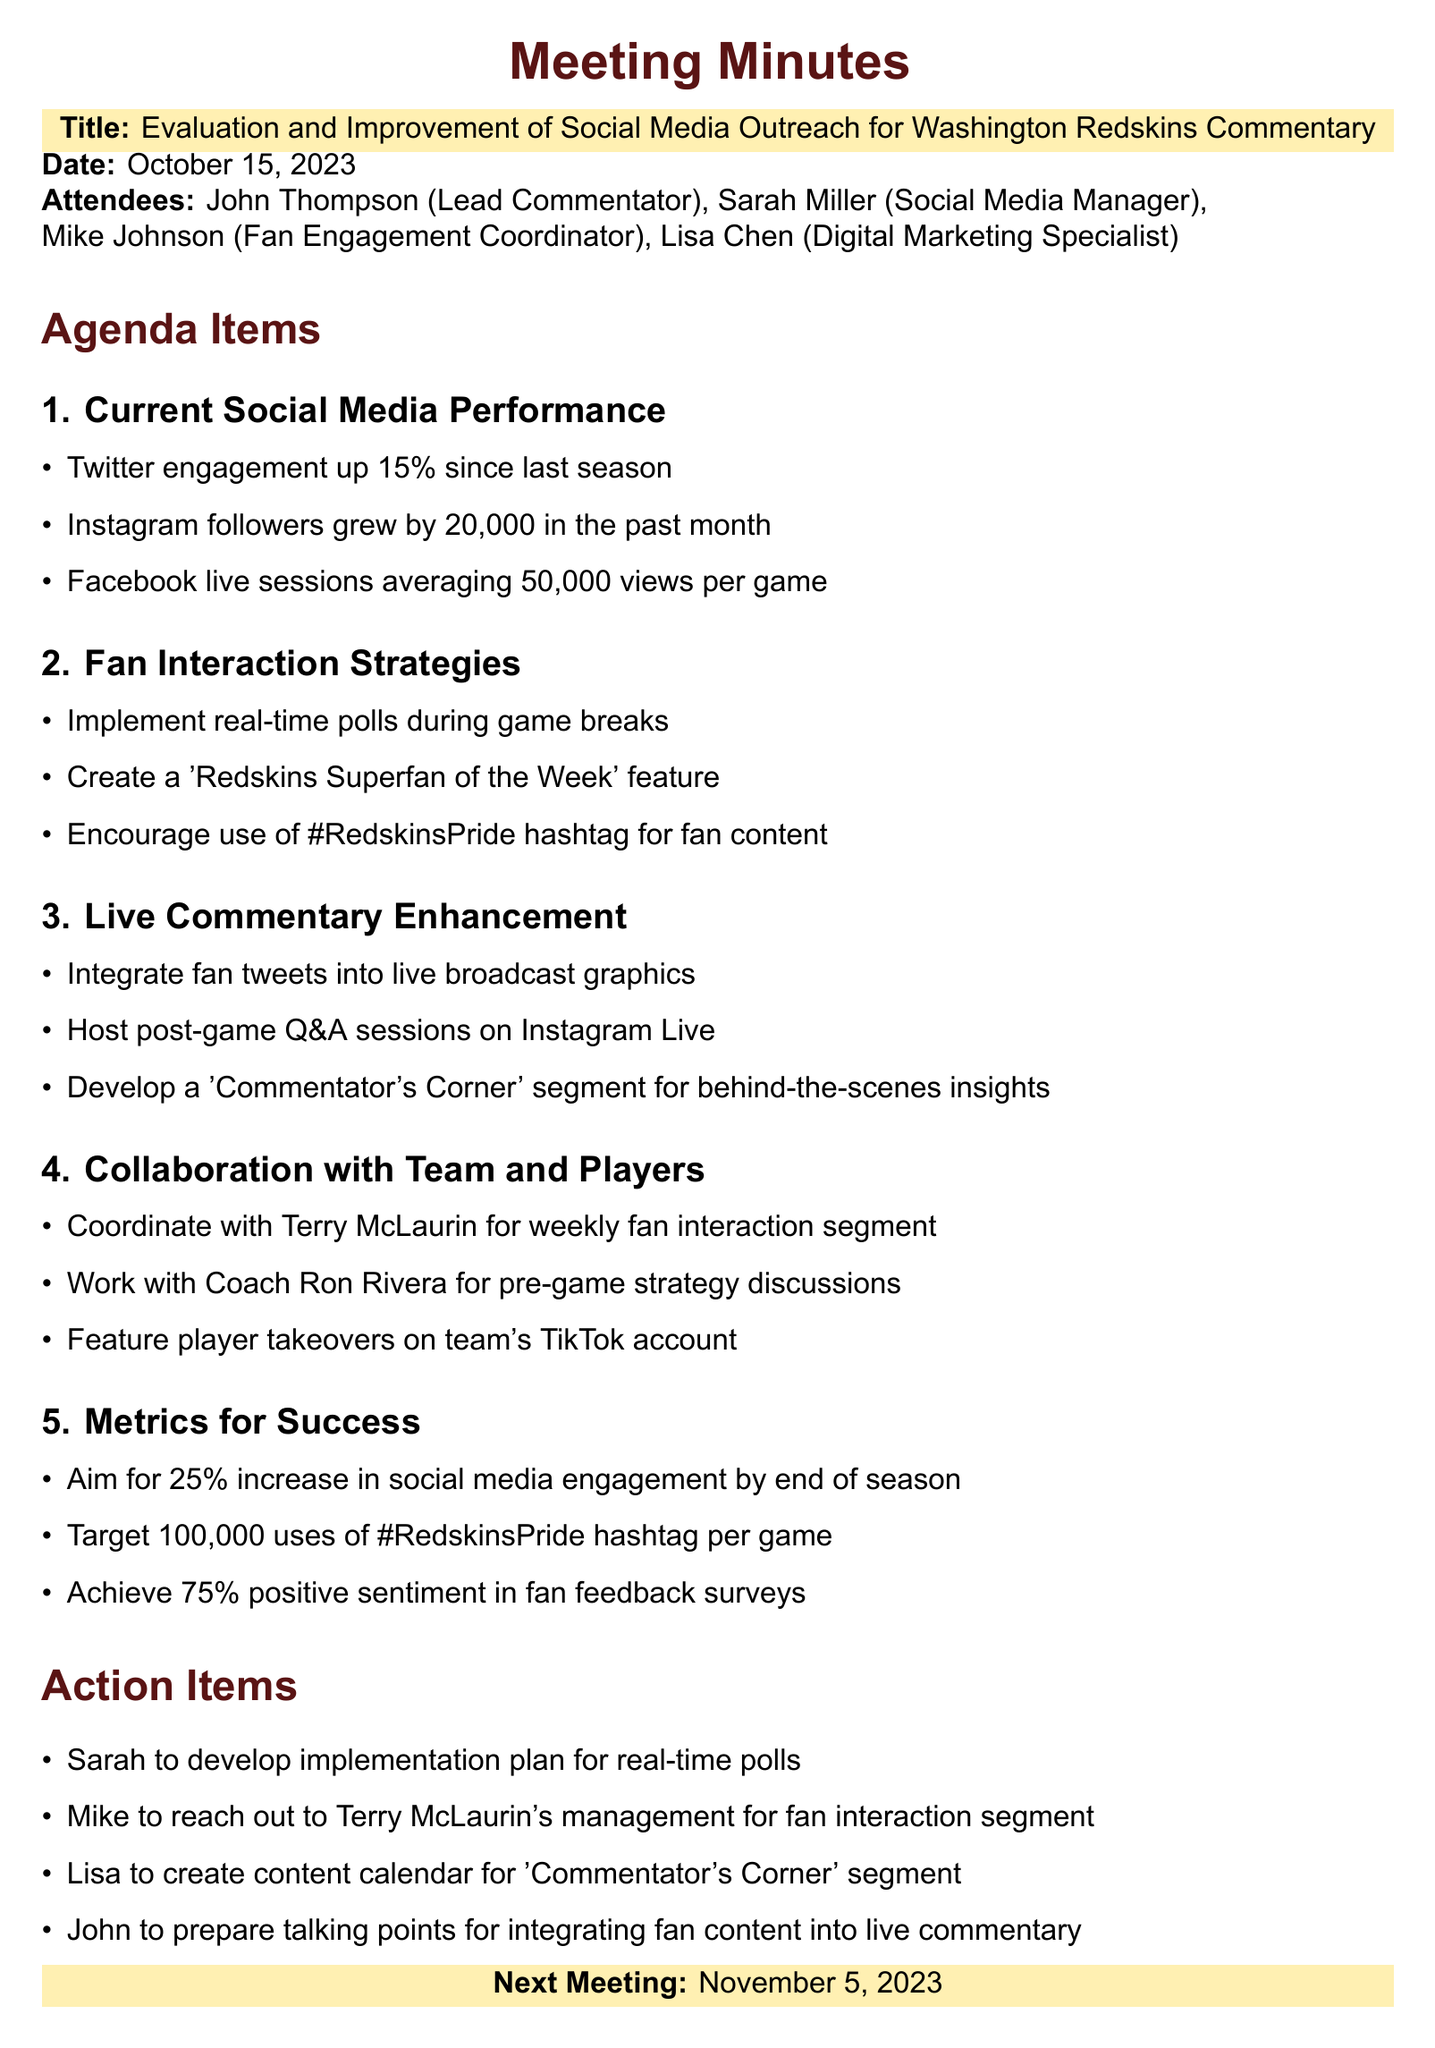What is the date of the meeting? The date of the meeting is explicitly stated in the document as "October 15, 2023."
Answer: October 15, 2023 Who is the Lead Commentator? The document lists John Thompson as the Lead Commentator among the attendees.
Answer: John Thompson What is the increase in Twitter engagement mentioned? The document states that Twitter engagement is up 15% since last season.
Answer: 15% What action item is Sarah responsible for? The document specifies that Sarah is to develop an implementation plan for real-time polls.
Answer: Develop implementation plan for real-time polls What is the target increase in social media engagement by the end of the season? The document indicates the aim for a 25% increase in social media engagement by the end of the season.
Answer: 25% Which player is mentioned for weekly fan interaction? The document identifies Terry McLaurin as the player to coordinate for a weekly fan interaction segment.
Answer: Terry McLaurin What hashtag is encouraged for fan content? The document encourages the use of the hashtag "#RedskinsPride" for fan content.
Answer: #RedskinsPride When is the next meeting scheduled? The next meeting date is clearly stated in the document as "November 5, 2023."
Answer: November 5, 2023 What social media platform will host post-game Q&A sessions? The document specifies that post-game Q&A sessions will be hosted on Instagram Live.
Answer: Instagram Live 